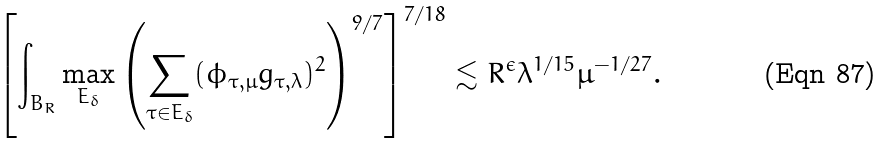Convert formula to latex. <formula><loc_0><loc_0><loc_500><loc_500>\left [ \int _ { B _ { R } } \underset { E _ { \delta } } { \max } \left ( \sum _ { \tau \in E _ { \delta } } ( \phi _ { \tau , \mu } g _ { \tau , \lambda } ) ^ { 2 } \right ) ^ { 9 / 7 } \right ] ^ { 7 / 1 8 } \lesssim R ^ { \epsilon } \lambda ^ { 1 / 1 5 } \mu ^ { - 1 / 2 7 } .</formula> 